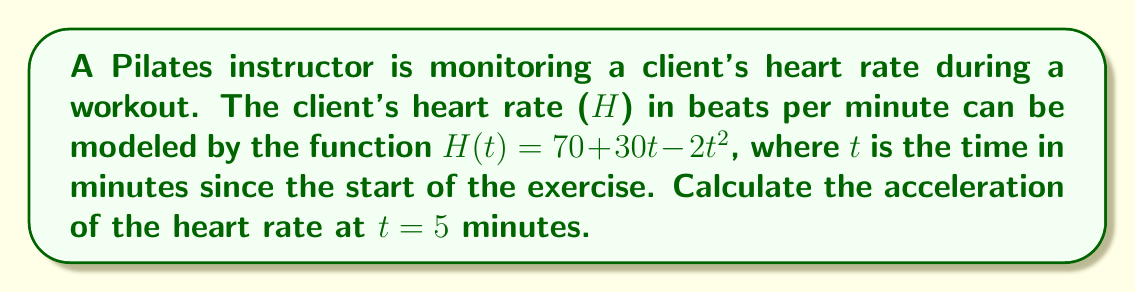Provide a solution to this math problem. To find the acceleration of the heart rate, we need to calculate the second derivative of the heart rate function H(t).

Step 1: Find the first derivative (velocity of heart rate change)
$H'(t) = \frac{d}{dt}(70 + 30t - 2t^2)$
$H'(t) = 30 - 4t$

Step 2: Find the second derivative (acceleration of heart rate change)
$H''(t) = \frac{d}{dt}(30 - 4t)$
$H''(t) = -4$

Step 3: Evaluate the second derivative at t = 5 minutes
$H''(5) = -4$

The negative value indicates that the heart rate is decelerating at a constant rate of 4 beats per minute squared.
Answer: $-4$ beats/min² 